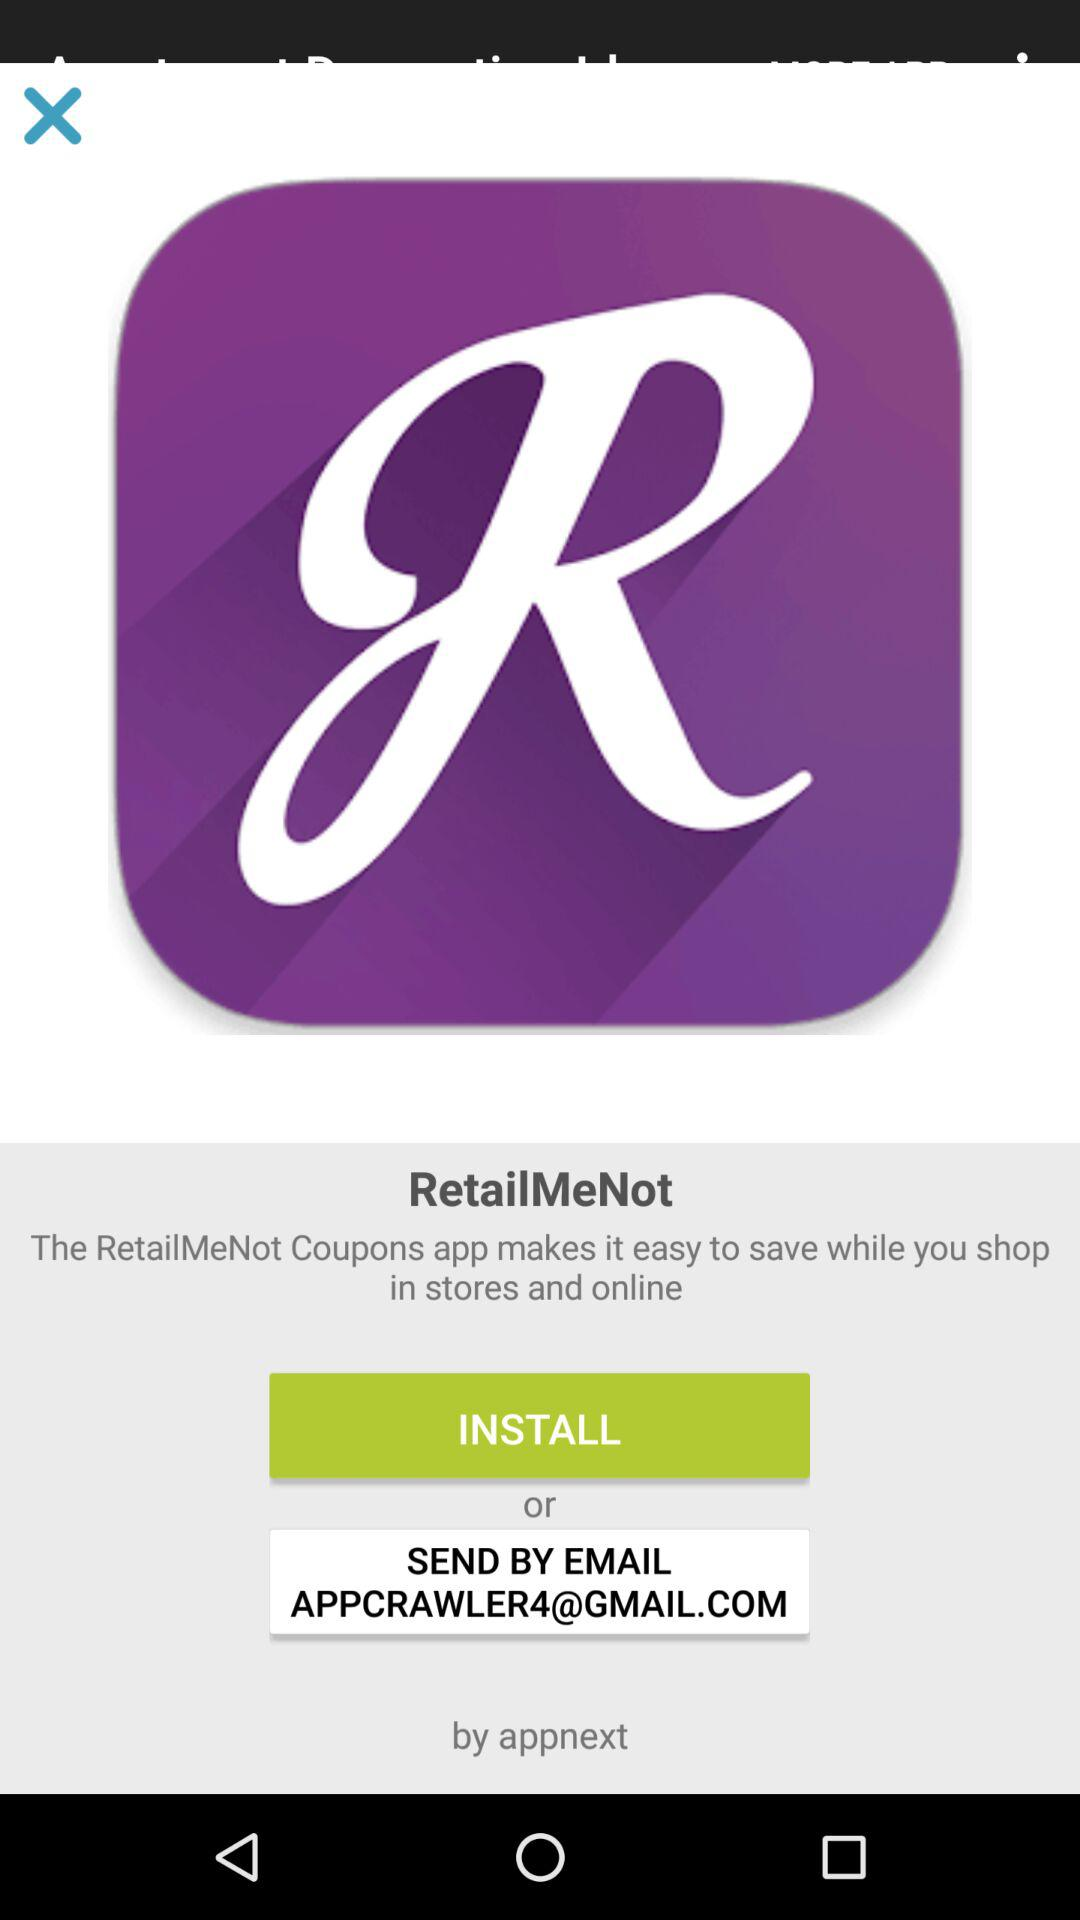What is the Gmail address? The Gmail address is appcrawler4@gmail.com. 